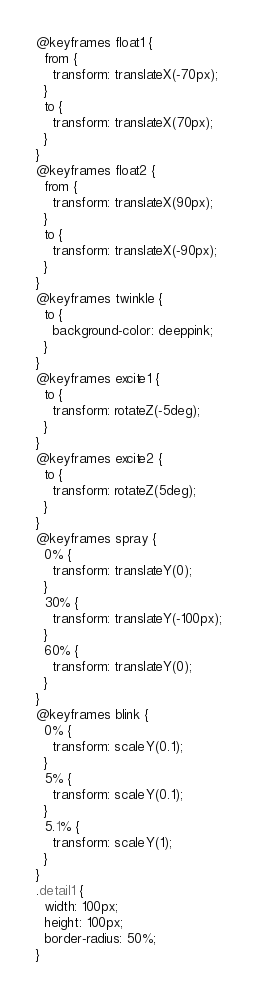<code> <loc_0><loc_0><loc_500><loc_500><_CSS_>@keyframes float1 {
  from {
    transform: translateX(-70px);
  }
  to {
    transform: translateX(70px);
  }
}
@keyframes float2 {
  from {
    transform: translateX(90px);
  }
  to {
    transform: translateX(-90px);
  }
}
@keyframes twinkle {
  to {
    background-color: deeppink;
  }
}
@keyframes excite1 {
  to {
    transform: rotateZ(-5deg);
  }
}
@keyframes excite2 {
  to {
    transform: rotateZ(5deg);
  }
}
@keyframes spray {
  0% {
    transform: translateY(0);
  }
  30% {
    transform: translateY(-100px);
  }
  60% {
    transform: translateY(0);
  }
}
@keyframes blink {
  0% {
    transform: scaleY(0.1);
  }
  5% {
    transform: scaleY(0.1);
  }
  5.1% {
    transform: scaleY(1);
  }
}
.detail1 {
  width: 100px;
  height: 100px;
  border-radius: 50%;
}
</code> 